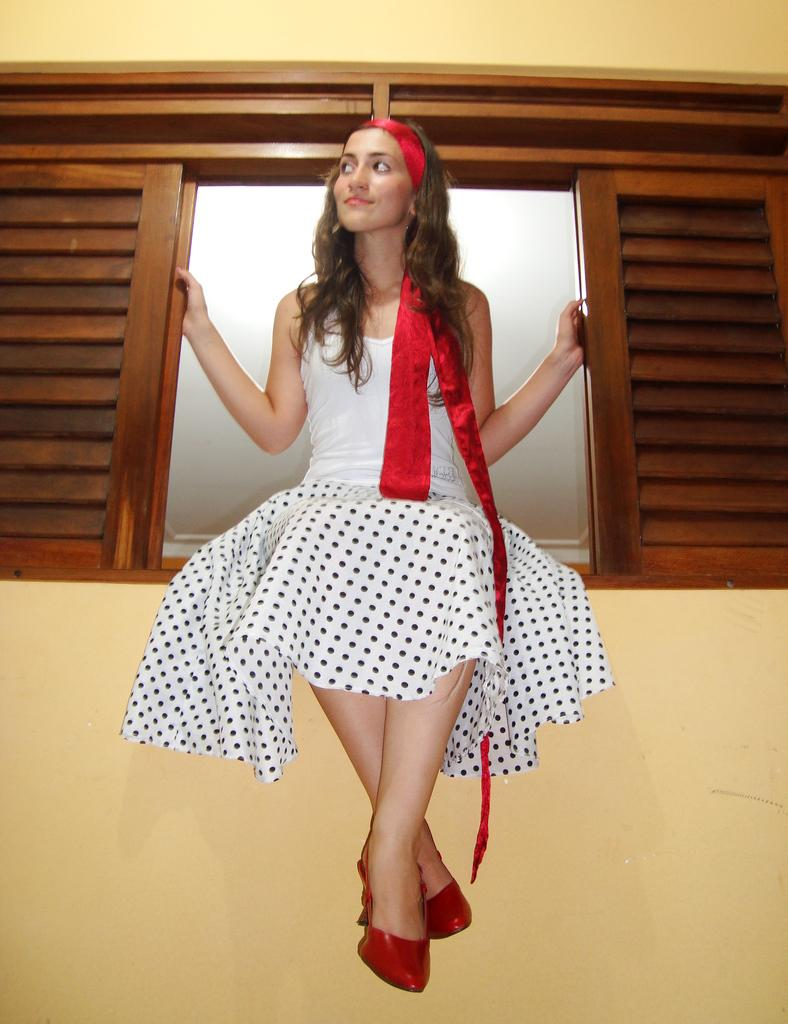Who is present in the image? There is a woman in the image. What is the woman wearing? The woman is wearing a dress with white, black, and red colors. Where is the woman sitting? The woman is sitting on a wooden window. What is the color of the wooden window? The wooden window is brown in color. What can be seen behind the woman? There is a cream-colored wall in the image. What type of sea creature can be seen swimming near the woman in the image? There is no sea creature present in the image; it is a woman sitting on a wooden window with a cream-colored wall in the background. 